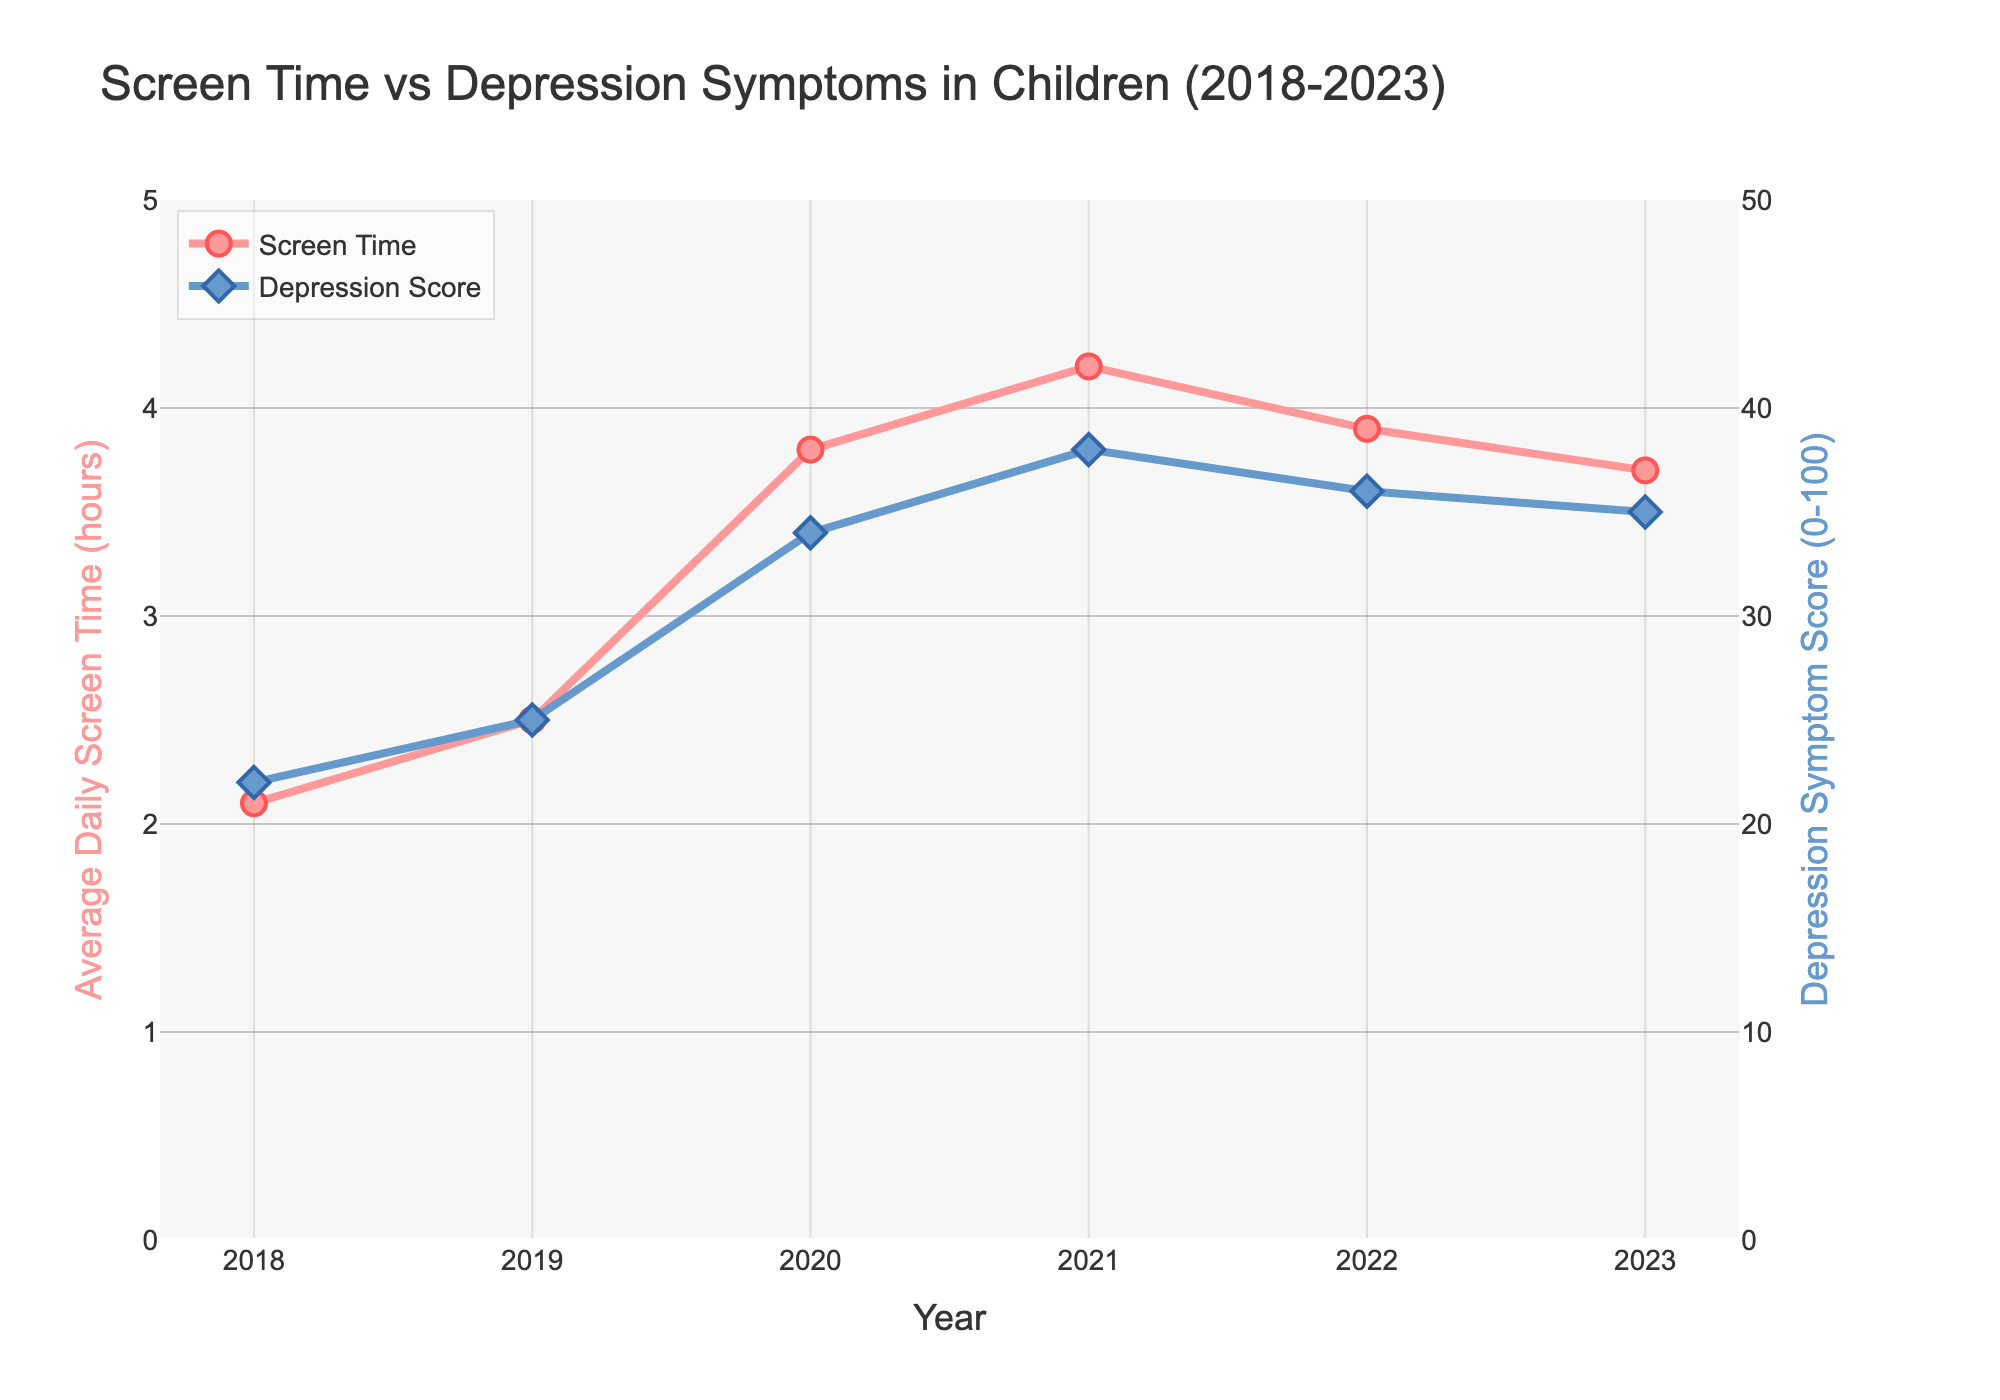What's the average screen time in 2022 and 2023? To find the average screen time in 2022 and 2023, add the screen time for both years and then divide by 2. For 2022, the screen time is 3.9 hours, and for 2023, it is 3.7 hours. The sum is 3.9 + 3.7 = 7.6, and the average is 7.6 / 2 = 3.8 hours.
Answer: 3.8 hours In which year did the depression symptom score peak? Find the year with the highest depression symptom score by comparing the values for each year. The scores are 22 (2018), 25 (2019), 34 (2020), 38 (2021), 36 (2022), and 35 (2023). The highest score is 38 in 2021.
Answer: 2021 Is there a visible correlation between screen time and depression symptom scores over the observed years? To determine the correlation, observe the trends of both lines. As screen time increases, depression scores also tend to increase, peaking around the same period. For instance, both metrics peak around 2021. This suggests a positive correlation.
Answer: Yes Which year saw the largest increase in depression symptoms compared to the previous year? Compare the depression scores year-over-year. The differences are 2019-2018: 25-22=3, 2020-2019: 34-25=9, 2021-2020: 38-34=4, 2022-2021: 36-38=-2, 2023-2022: 35-36=-1. The largest increase of 9 is from 2019 to 2020.
Answer: 2020 Did screen time decrease in any year? If so, which year? Look at the screen time values for each year. It decreased from 2021 (4.2 hours) to 2022 (3.9 hours) and from 2022 (3.9 hours) to 2023 (3.7 hours).
Answer: 2022 and 2023 What is the total increase in screen time from 2018 to 2021? Subtract the 2018 screen time from the 2021 screen time. For 2018, the screen time is 2.1 hours, and for 2021, it is 4.2 hours. The increase is 4.2 - 2.1 = 2.1 hours.
Answer: 2.1 hours Are there any years when both screen time and depression scores decreased compared to the previous year? Compare year-over-year values for both screen time and depression scores. In 2022, both screen time (4.2 to 3.9) and depression scores (38 to 36) decreased from the previous year.
Answer: 2022 What is the sum of the depression symptom scores for all the years combined? Sum the scores for each year: 22 (2018) + 25 (2019) + 34 (2020) + 38 (2021) + 36 (2022) + 35 (2023). The total is 22 + 25 + 34 + 38 + 36 + 35 = 190.
Answer: 190 